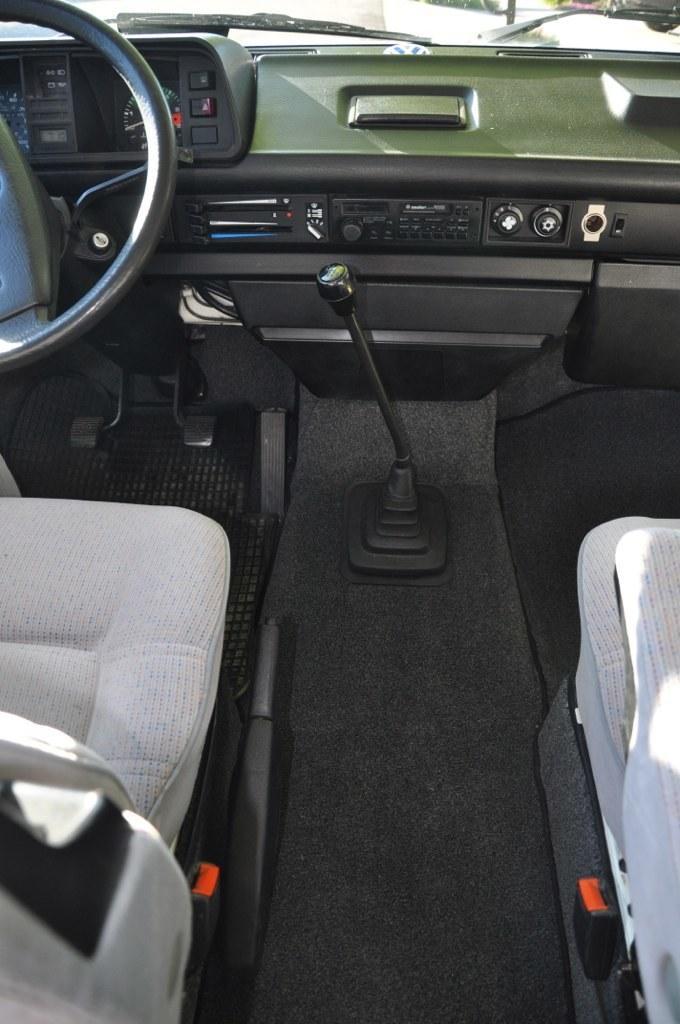Could you give a brief overview of what you see in this image? The picture is taken inside a vehicle. Here there are seats. This is the steering wheel. These are switches. This is the wiper. 